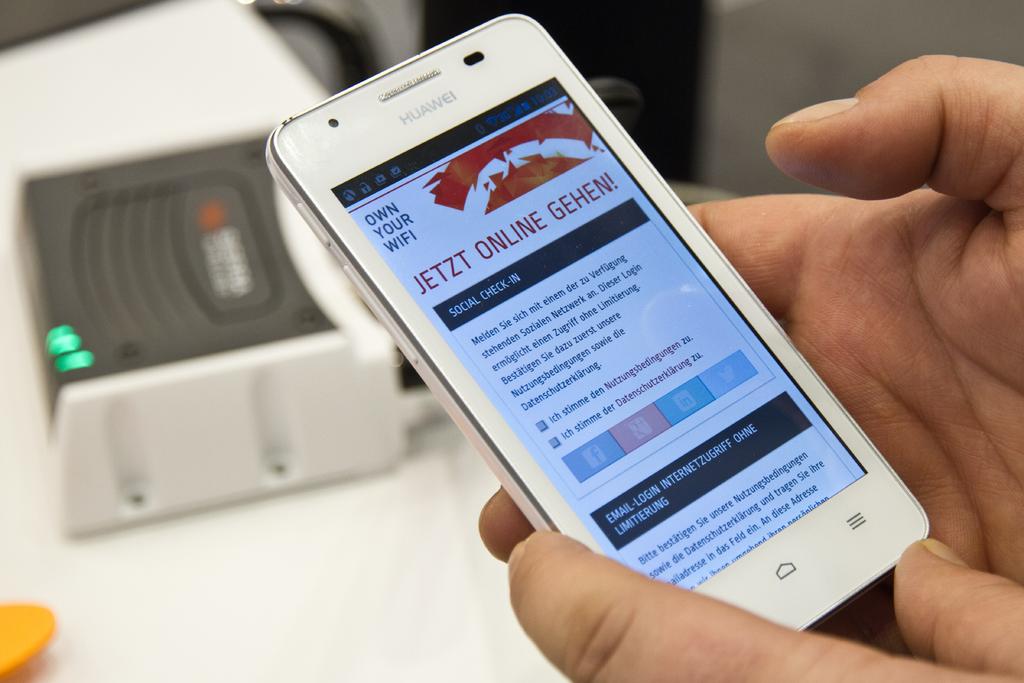What is the site asking us to own?
Your response must be concise. Wifi. 